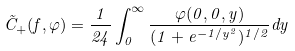Convert formula to latex. <formula><loc_0><loc_0><loc_500><loc_500>\tilde { C } _ { + } ( f , \varphi ) = \frac { 1 } { 2 4 } \int _ { 0 } ^ { \infty } \frac { \varphi ( 0 , 0 , y ) } { ( 1 + e ^ { - 1 / y ^ { 2 } } ) ^ { 1 / 2 } } d y</formula> 